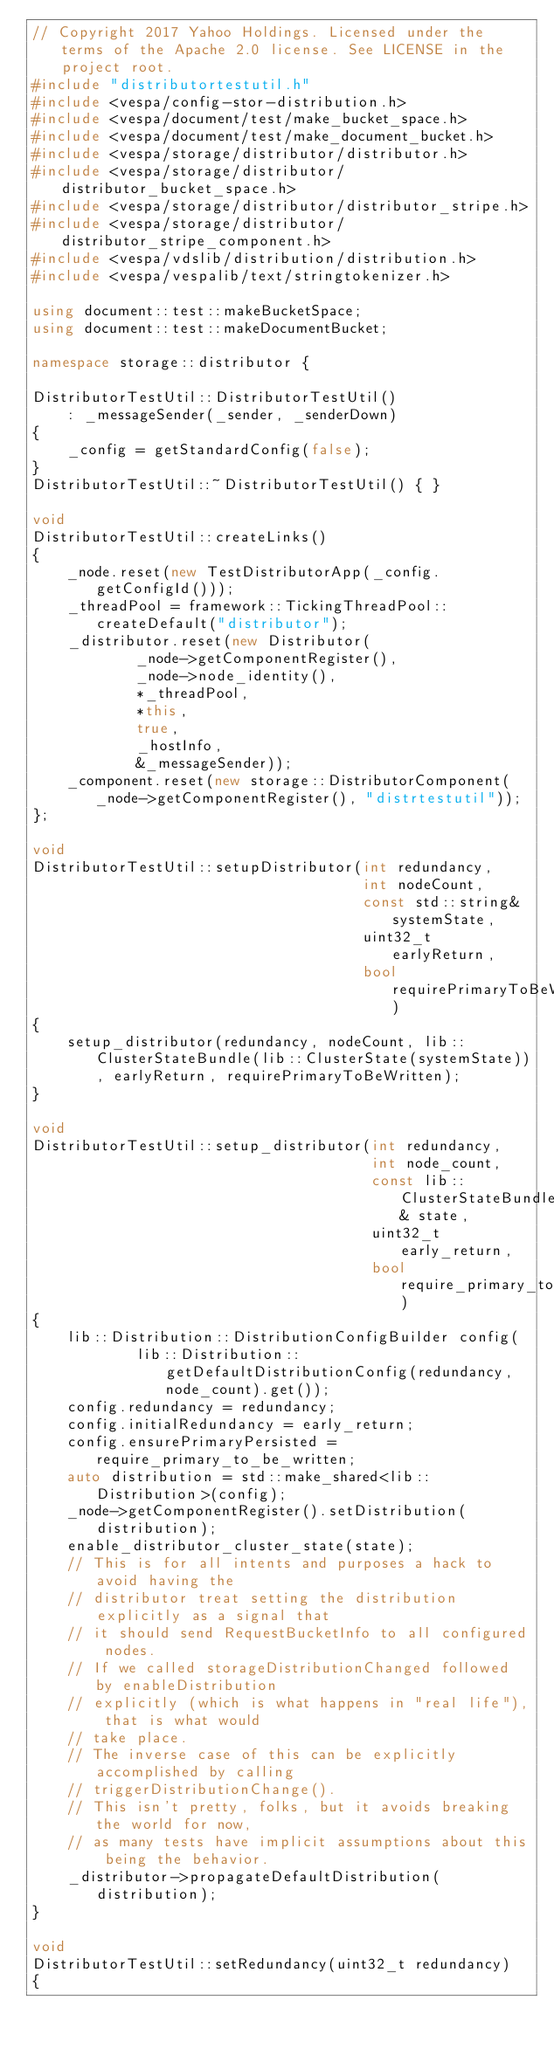<code> <loc_0><loc_0><loc_500><loc_500><_C++_>// Copyright 2017 Yahoo Holdings. Licensed under the terms of the Apache 2.0 license. See LICENSE in the project root.
#include "distributortestutil.h"
#include <vespa/config-stor-distribution.h>
#include <vespa/document/test/make_bucket_space.h>
#include <vespa/document/test/make_document_bucket.h>
#include <vespa/storage/distributor/distributor.h>
#include <vespa/storage/distributor/distributor_bucket_space.h>
#include <vespa/storage/distributor/distributor_stripe.h>
#include <vespa/storage/distributor/distributor_stripe_component.h>
#include <vespa/vdslib/distribution/distribution.h>
#include <vespa/vespalib/text/stringtokenizer.h>

using document::test::makeBucketSpace;
using document::test::makeDocumentBucket;

namespace storage::distributor {

DistributorTestUtil::DistributorTestUtil()
    : _messageSender(_sender, _senderDown)
{
    _config = getStandardConfig(false);
}
DistributorTestUtil::~DistributorTestUtil() { }

void
DistributorTestUtil::createLinks()
{
    _node.reset(new TestDistributorApp(_config.getConfigId()));
    _threadPool = framework::TickingThreadPool::createDefault("distributor");
    _distributor.reset(new Distributor(
            _node->getComponentRegister(),
            _node->node_identity(),
            *_threadPool,
            *this,
            true,
            _hostInfo,
            &_messageSender));
    _component.reset(new storage::DistributorComponent(_node->getComponentRegister(), "distrtestutil"));
};

void
DistributorTestUtil::setupDistributor(int redundancy,
                                      int nodeCount,
                                      const std::string& systemState,
                                      uint32_t earlyReturn,
                                      bool requirePrimaryToBeWritten)
{
    setup_distributor(redundancy, nodeCount, lib::ClusterStateBundle(lib::ClusterState(systemState)), earlyReturn, requirePrimaryToBeWritten);
}

void
DistributorTestUtil::setup_distributor(int redundancy,
                                       int node_count,
                                       const lib::ClusterStateBundle& state,
                                       uint32_t early_return,
                                       bool require_primary_to_be_written)
{
    lib::Distribution::DistributionConfigBuilder config(
            lib::Distribution::getDefaultDistributionConfig(redundancy, node_count).get());
    config.redundancy = redundancy;
    config.initialRedundancy = early_return;
    config.ensurePrimaryPersisted = require_primary_to_be_written;
    auto distribution = std::make_shared<lib::Distribution>(config);
    _node->getComponentRegister().setDistribution(distribution);
    enable_distributor_cluster_state(state);
    // This is for all intents and purposes a hack to avoid having the
    // distributor treat setting the distribution explicitly as a signal that
    // it should send RequestBucketInfo to all configured nodes.
    // If we called storageDistributionChanged followed by enableDistribution
    // explicitly (which is what happens in "real life"), that is what would
    // take place.
    // The inverse case of this can be explicitly accomplished by calling
    // triggerDistributionChange().
    // This isn't pretty, folks, but it avoids breaking the world for now,
    // as many tests have implicit assumptions about this being the behavior.
    _distributor->propagateDefaultDistribution(distribution);
}

void
DistributorTestUtil::setRedundancy(uint32_t redundancy)
{</code> 